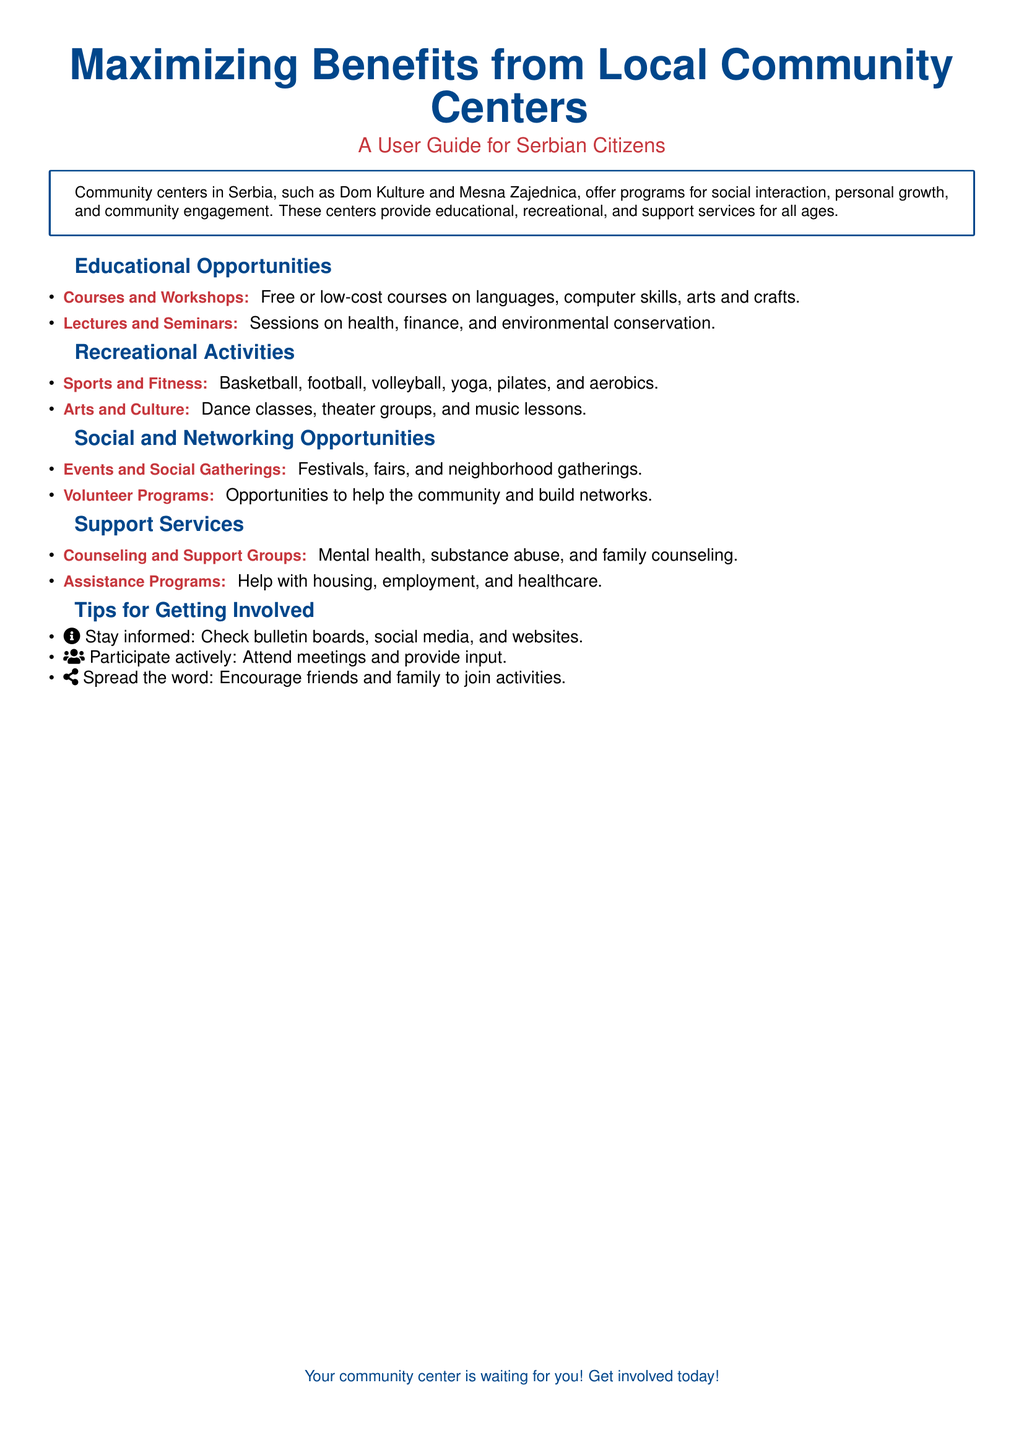What are some programs offered by community centers? The document states that community centers offer educational, recreational, and support services.
Answer: Educational, recreational, and support services What types of courses are available? The document lists free or low-cost courses on languages, computer skills, arts and crafts.
Answer: Languages, computer skills, arts and crafts What kind of support services does the community center provide? The document mentions counseling and support groups, and assistance programs as services provided.
Answer: Counseling and support groups, assistance programs What recreational activities can I participate in? The document specifies sports and fitness, and arts and culture activities.
Answer: Sports and fitness, arts and culture How can I stay informed about activities? The document suggests checking bulletin boards, social media, and websites for information.
Answer: Bulletin boards, social media, websites What is a way to encourage community participation? The document advises spreading the word to encourage friends and family to join activities.
Answer: Spread the word What types of events are organized at community centers? The document includes festivals, fairs, and neighborhood gatherings as types of events.
Answer: Festivals, fairs, neighborhood gatherings What is an example of volunteering opportunity mentioned? The document lists volunteer programs as an avenue to help the community.
Answer: Volunteer programs What benefits do community centers provide to individuals? The document highlights personal growth and community engagement as key benefits.
Answer: Personal growth, community engagement 